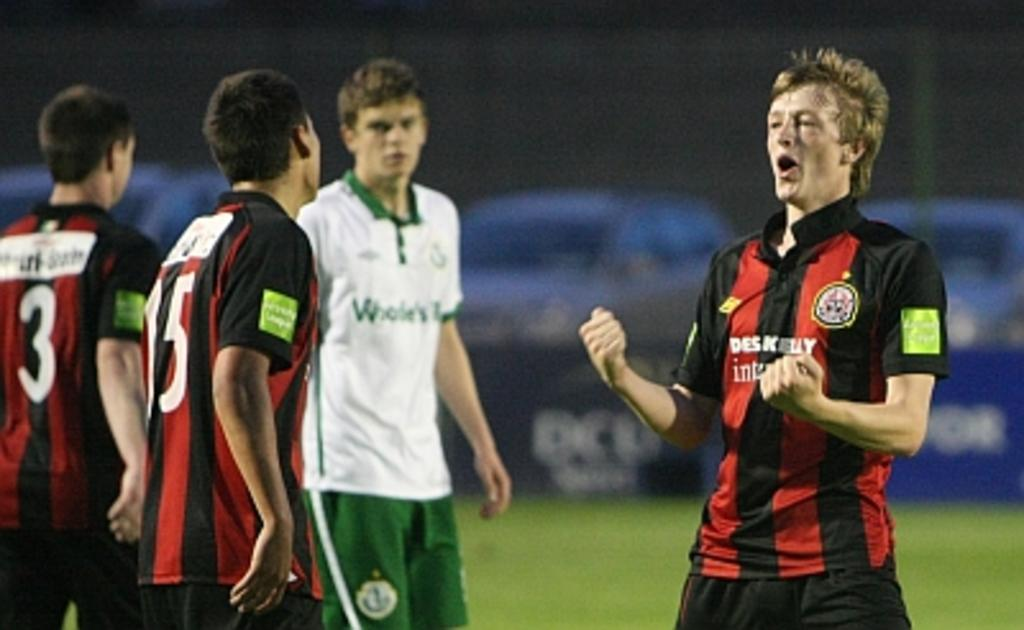<image>
Offer a succinct explanation of the picture presented. a few players with one wearing the number 3 